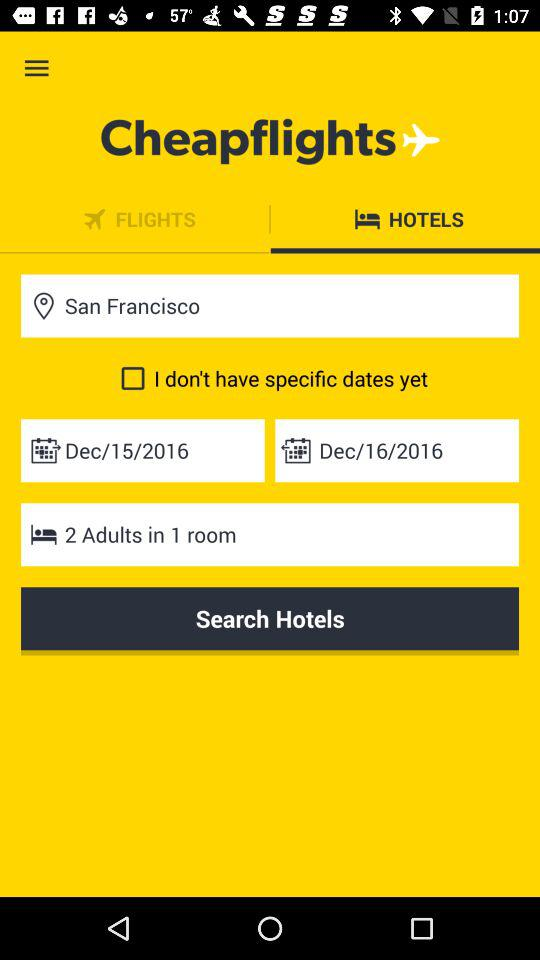What is the mentioned location? The mentioned location is San Francisco. 